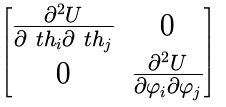<formula> <loc_0><loc_0><loc_500><loc_500>\begin{bmatrix} \frac { \partial ^ { 2 } U } { \partial \ t h _ { i } \partial \ t h _ { j } } & 0 \\ 0 & \frac { \partial ^ { 2 } U } { \partial \varphi _ { i } \partial \varphi _ { j } } \end{bmatrix}</formula> 